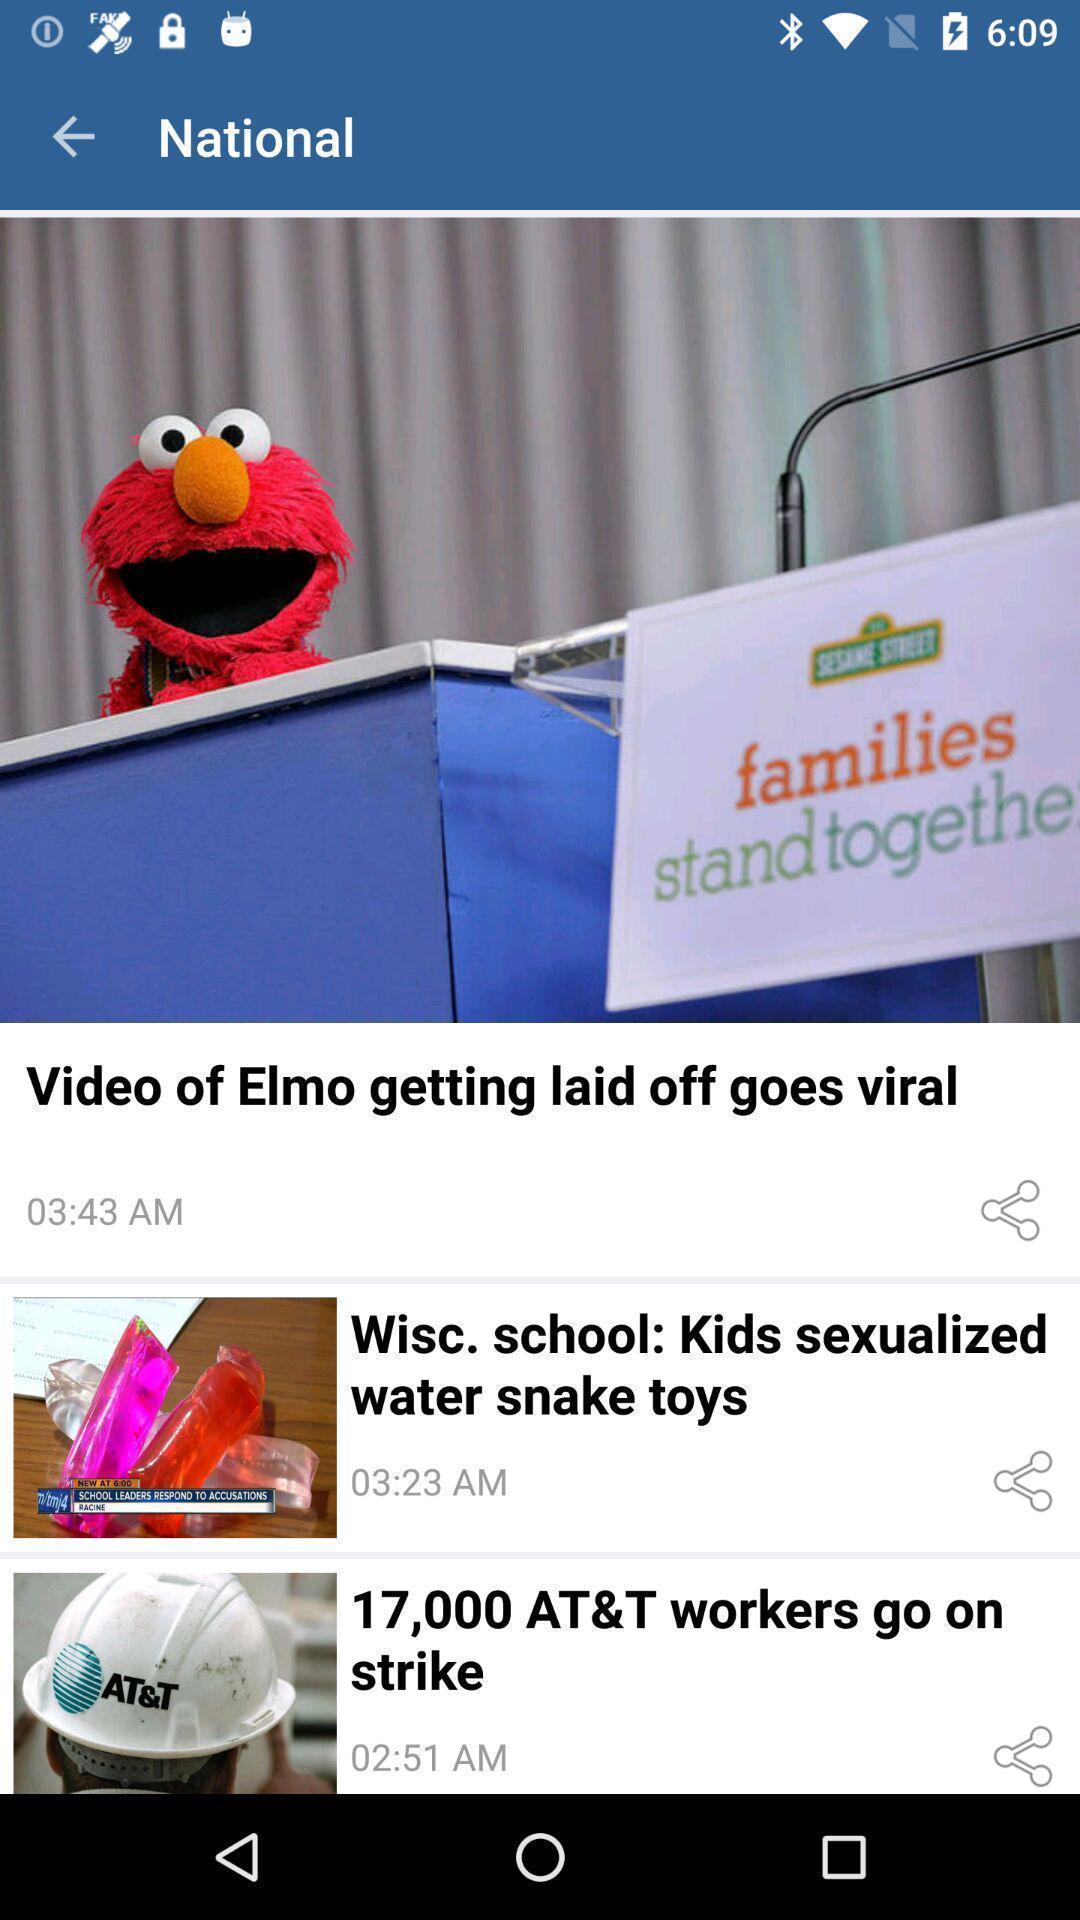Explain what's happening in this screen capture. Various kinds of news in the application. 